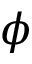Convert formula to latex. <formula><loc_0><loc_0><loc_500><loc_500>\phi</formula> 